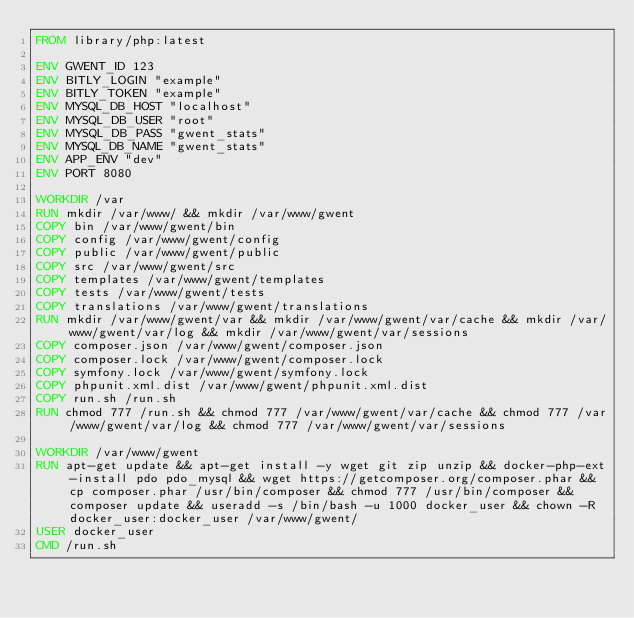<code> <loc_0><loc_0><loc_500><loc_500><_Dockerfile_>FROM library/php:latest

ENV GWENT_ID 123
ENV BITLY_LOGIN "example"
ENV BITLY_TOKEN "example"
ENV MYSQL_DB_HOST "localhost"
ENV MYSQL_DB_USER "root"
ENV MYSQL_DB_PASS "gwent_stats"
ENV MYSQL_DB_NAME "gwent_stats"
ENV APP_ENV "dev"
ENV PORT 8080

WORKDIR /var
RUN mkdir /var/www/ && mkdir /var/www/gwent
COPY bin /var/www/gwent/bin
COPY config /var/www/gwent/config
COPY public /var/www/gwent/public
COPY src /var/www/gwent/src
COPY templates /var/www/gwent/templates
COPY tests /var/www/gwent/tests
COPY translations /var/www/gwent/translations
RUN mkdir /var/www/gwent/var && mkdir /var/www/gwent/var/cache && mkdir /var/www/gwent/var/log && mkdir /var/www/gwent/var/sessions
COPY composer.json /var/www/gwent/composer.json
COPY composer.lock /var/www/gwent/composer.lock
COPY symfony.lock /var/www/gwent/symfony.lock
COPY phpunit.xml.dist /var/www/gwent/phpunit.xml.dist
COPY run.sh /run.sh
RUN chmod 777 /run.sh && chmod 777 /var/www/gwent/var/cache && chmod 777 /var/www/gwent/var/log && chmod 777 /var/www/gwent/var/sessions

WORKDIR /var/www/gwent
RUN apt-get update && apt-get install -y wget git zip unzip && docker-php-ext-install pdo pdo_mysql && wget https://getcomposer.org/composer.phar && cp composer.phar /usr/bin/composer && chmod 777 /usr/bin/composer && composer update && useradd -s /bin/bash -u 1000 docker_user && chown -R docker_user:docker_user /var/www/gwent/
USER docker_user
CMD /run.sh

</code> 